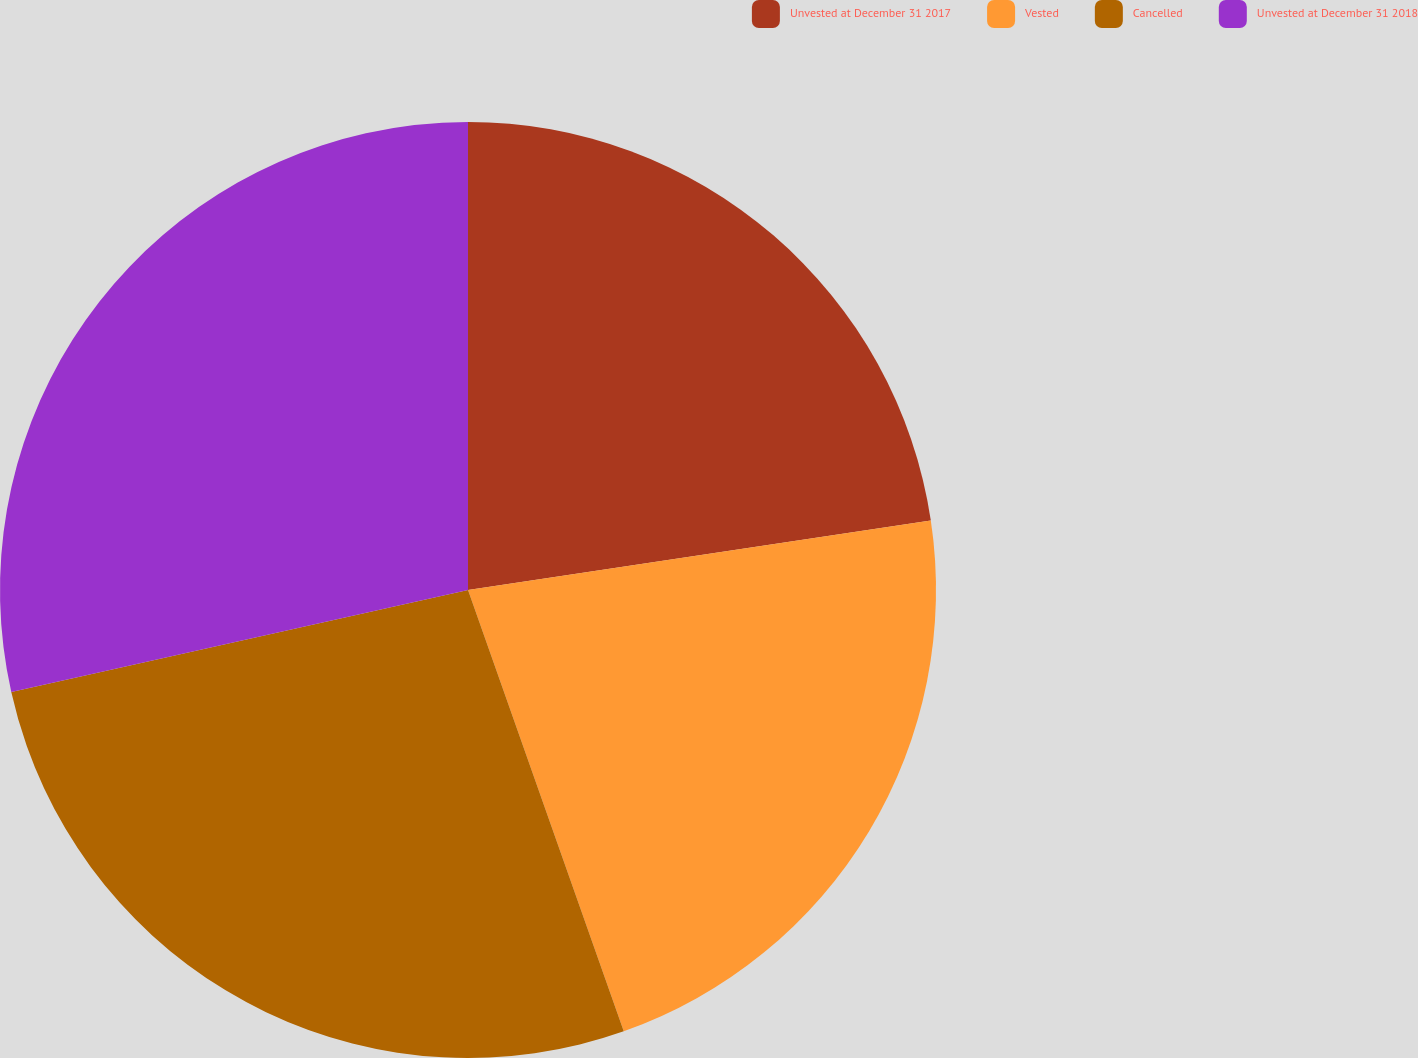<chart> <loc_0><loc_0><loc_500><loc_500><pie_chart><fcel>Unvested at December 31 2017<fcel>Vested<fcel>Cancelled<fcel>Unvested at December 31 2018<nl><fcel>22.63%<fcel>21.97%<fcel>26.9%<fcel>28.5%<nl></chart> 